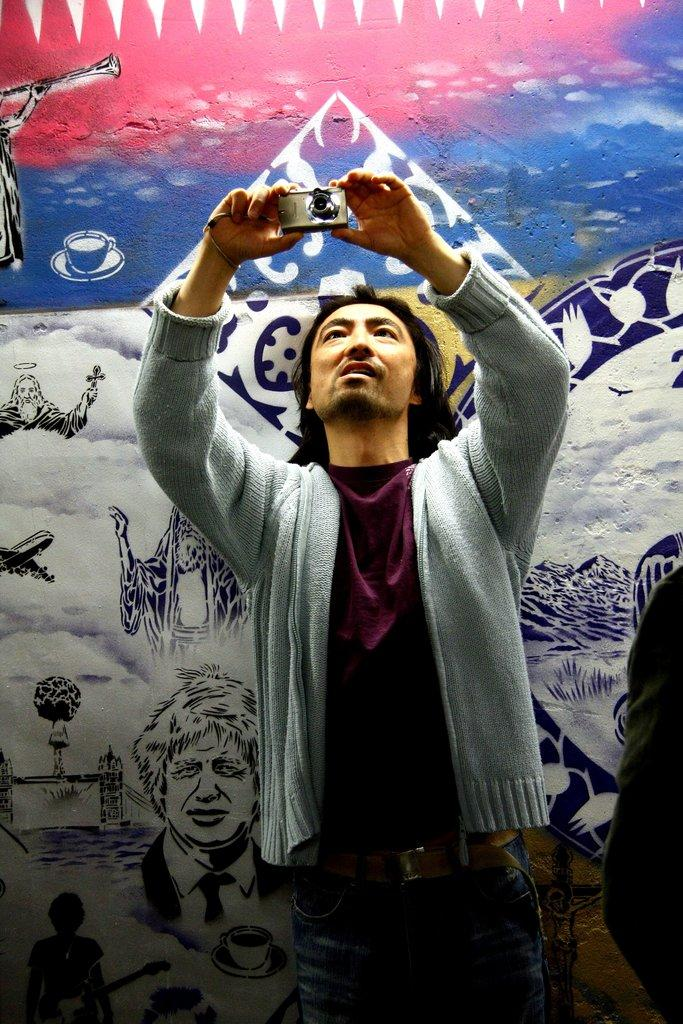What is the person in the image doing? The person is standing in the image and holding a camera in his hands. What can be seen in the background of the image? There is a wall in the background of the image. Is there anything on the wall in the image? Yes, there is a painting on the wall. What type of boot is hanging from the person's neck in the image? There is no boot hanging from the person's neck in the image. Can you describe the snail crawling on the painting in the image? There is no snail present on the painting or in the image. 